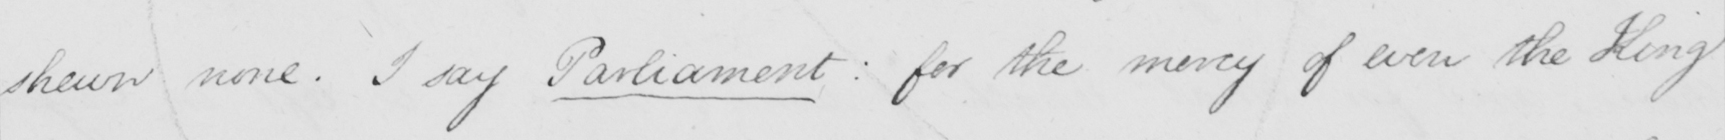What is written in this line of handwriting? shewn none . I say Parliament :  for the mercy of even the King 